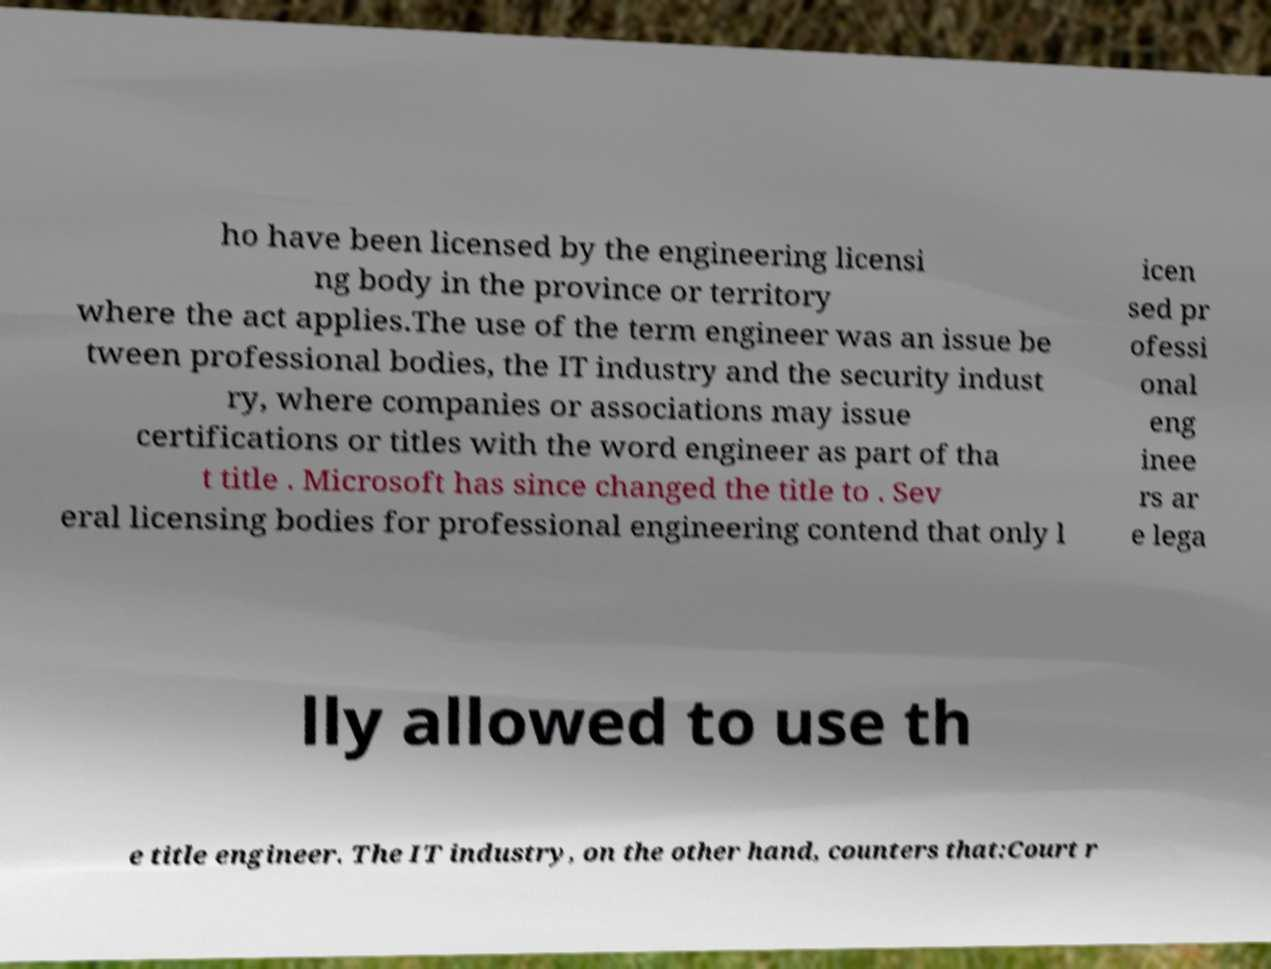Can you accurately transcribe the text from the provided image for me? ho have been licensed by the engineering licensi ng body in the province or territory where the act applies.The use of the term engineer was an issue be tween professional bodies, the IT industry and the security indust ry, where companies or associations may issue certifications or titles with the word engineer as part of tha t title . Microsoft has since changed the title to . Sev eral licensing bodies for professional engineering contend that only l icen sed pr ofessi onal eng inee rs ar e lega lly allowed to use th e title engineer. The IT industry, on the other hand, counters that:Court r 